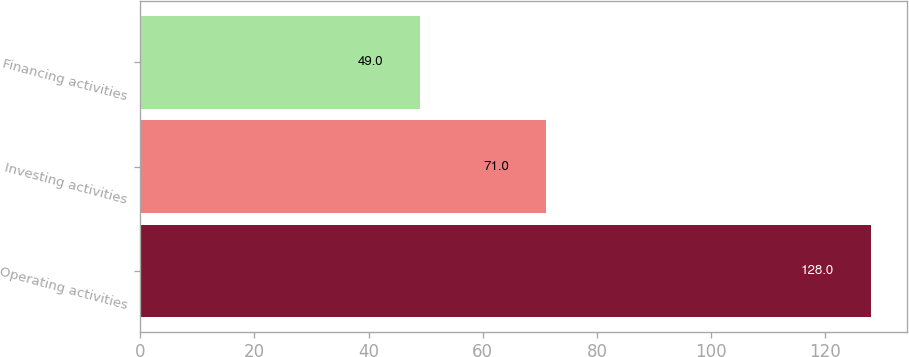<chart> <loc_0><loc_0><loc_500><loc_500><bar_chart><fcel>Operating activities<fcel>Investing activities<fcel>Financing activities<nl><fcel>128<fcel>71<fcel>49<nl></chart> 